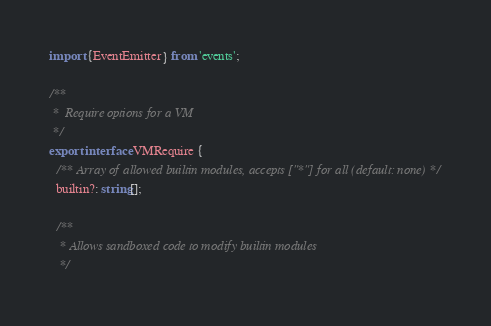<code> <loc_0><loc_0><loc_500><loc_500><_TypeScript_>import {EventEmitter} from 'events';

/**
 *  Require options for a VM
 */
export interface VMRequire {
  /** Array of allowed builtin modules, accepts ["*"] for all (default: none) */
  builtin?: string[];

  /**
   * Allows sandboxed code to modify builtin modules
   */</code> 